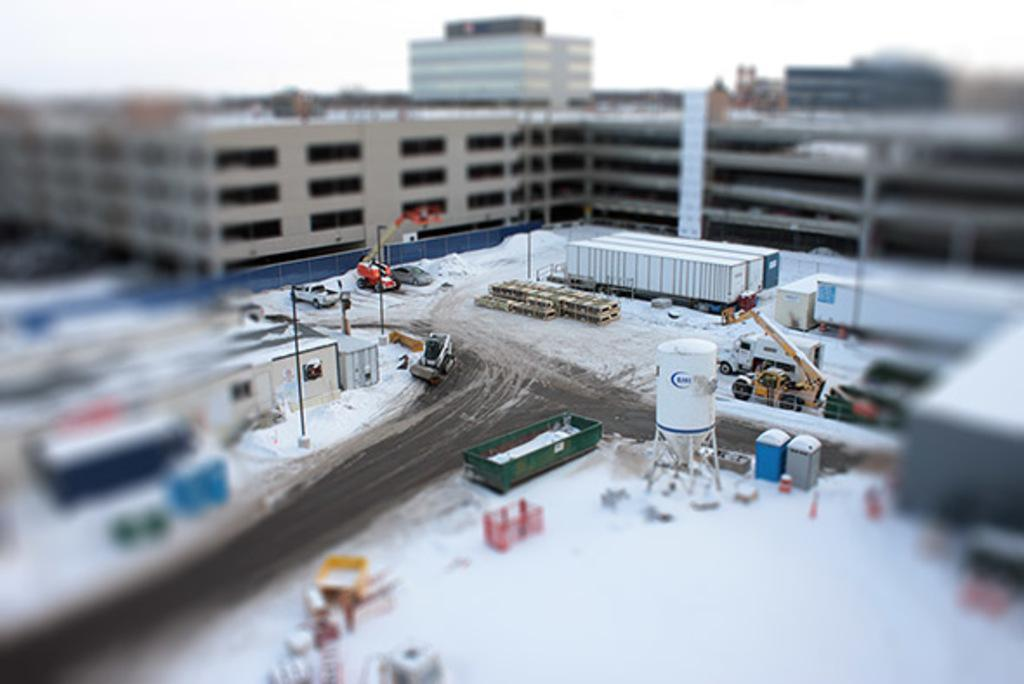What type of structures can be seen in the image? There are buildings in the image. What else is present in the image besides buildings? There are vehicles and a crane visible in the image. Are there any other objects or features in the image? Yes, there are poles in the image. What can be seen in the background of the image? The sky is visible in the image. What type of iron is being used in the protest in the image? There is no protest or iron present in the image; it features buildings, vehicles, a crane, and poles. Can you tell me how many people are in jail in the image? There is no jail or people in jail present in the image. 